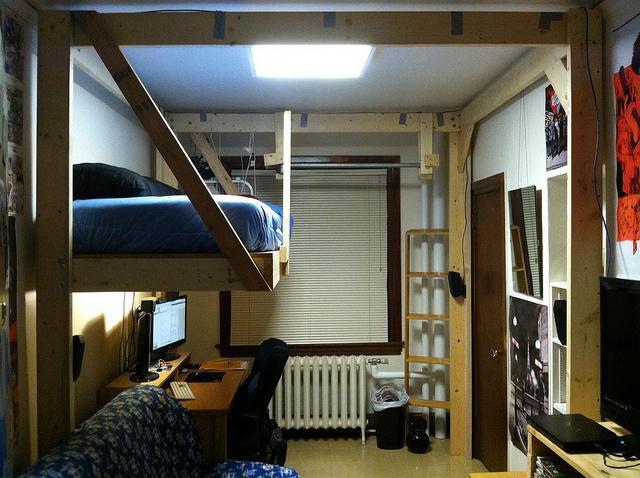How many tvs can be seen?
Give a very brief answer. 2. 